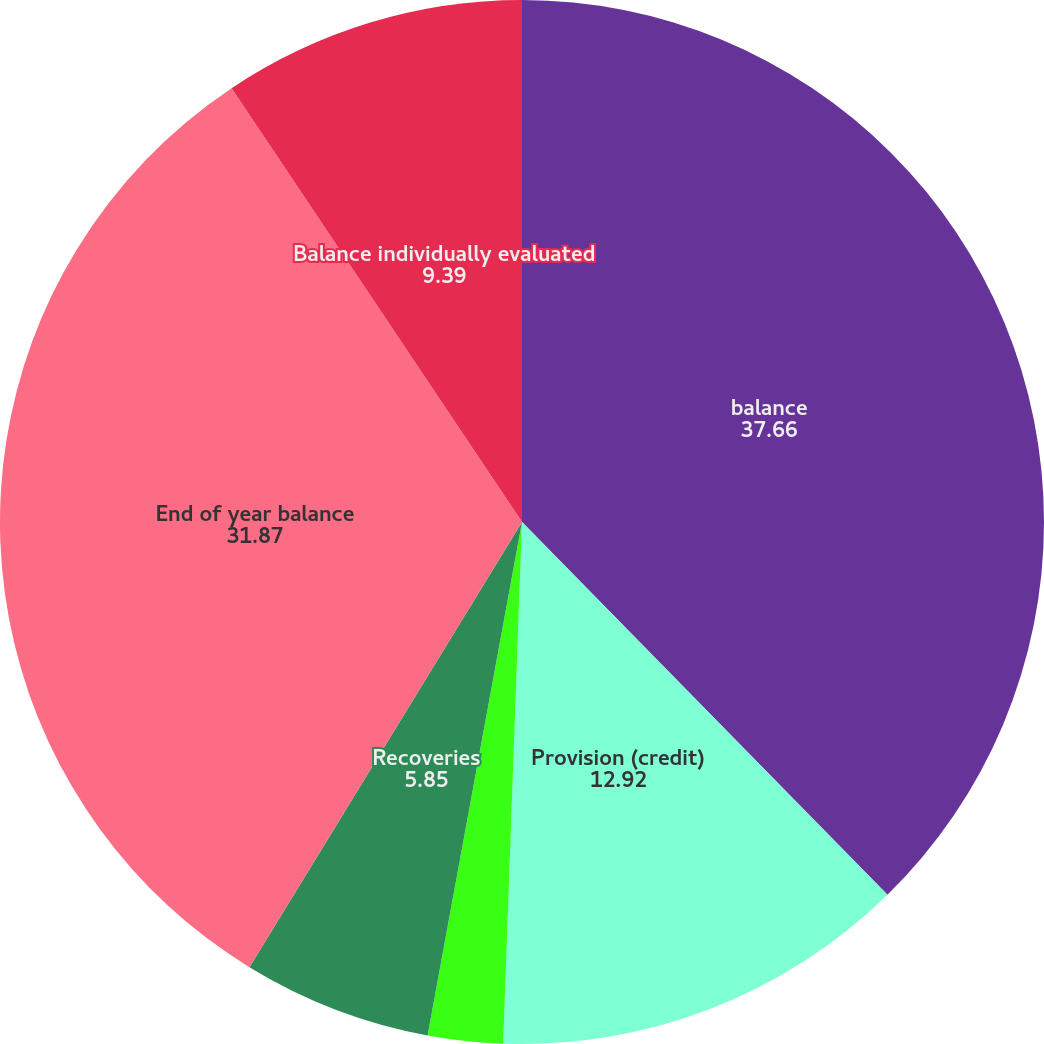<chart> <loc_0><loc_0><loc_500><loc_500><pie_chart><fcel>balance<fcel>Provision (credit)<fcel>Write-offs<fcel>Recoveries<fcel>End of year balance<fcel>Balance individually evaluated<nl><fcel>37.66%<fcel>12.92%<fcel>2.32%<fcel>5.85%<fcel>31.87%<fcel>9.39%<nl></chart> 